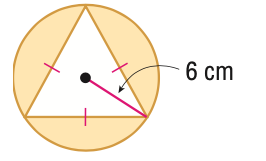Answer the mathemtical geometry problem and directly provide the correct option letter.
Question: Find the area of the shaded region. Round to the nearest tenth.
Choices: A: 19.6 B: 46.8 C: 66.3 D: 113.1 C 